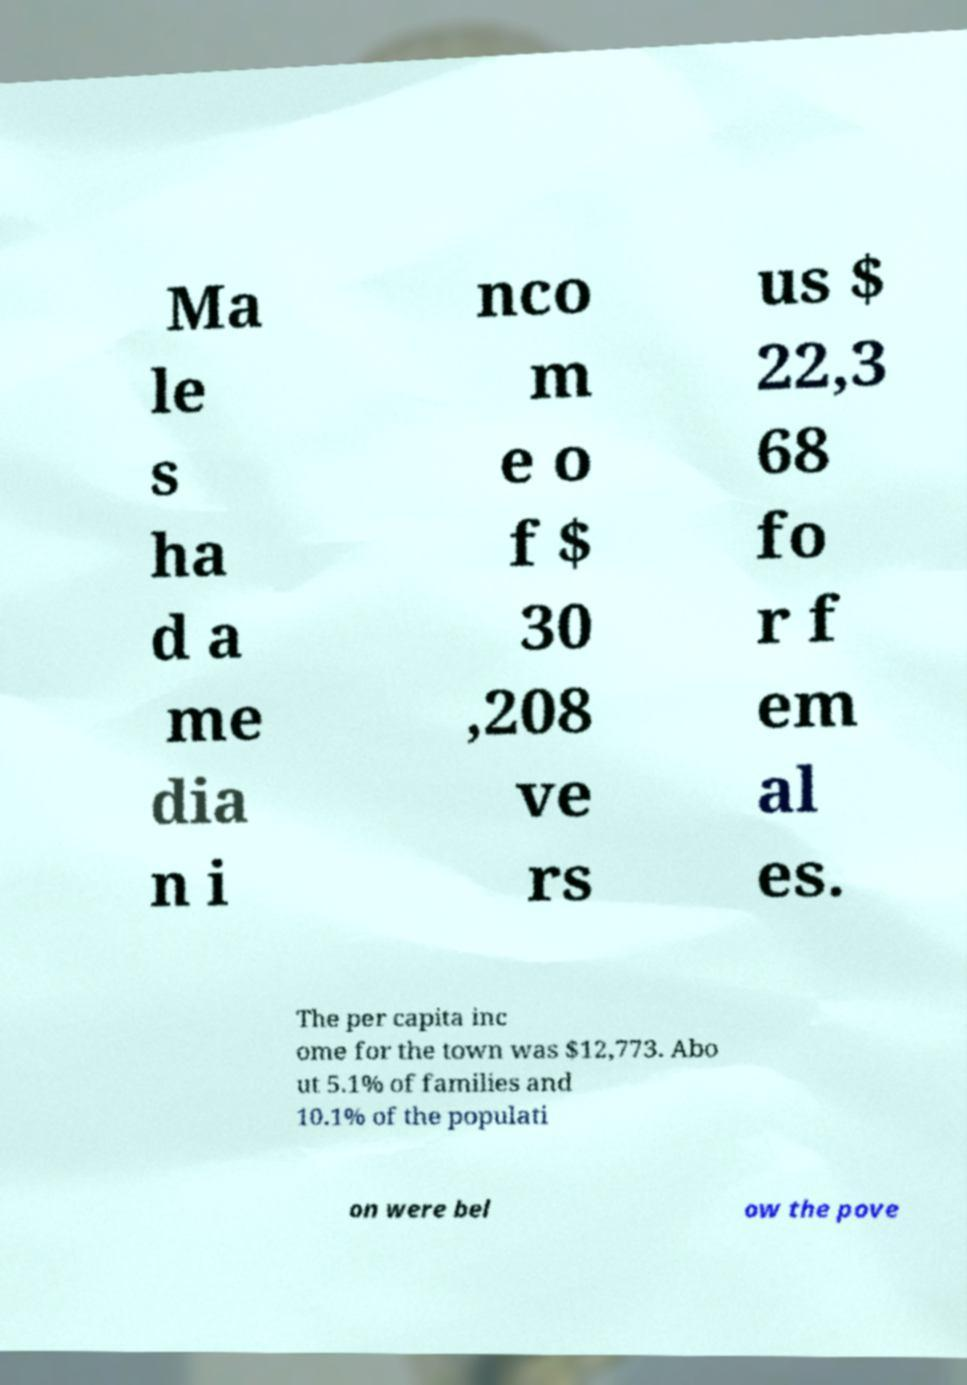What messages or text are displayed in this image? I need them in a readable, typed format. Ma le s ha d a me dia n i nco m e o f $ 30 ,208 ve rs us $ 22,3 68 fo r f em al es. The per capita inc ome for the town was $12,773. Abo ut 5.1% of families and 10.1% of the populati on were bel ow the pove 